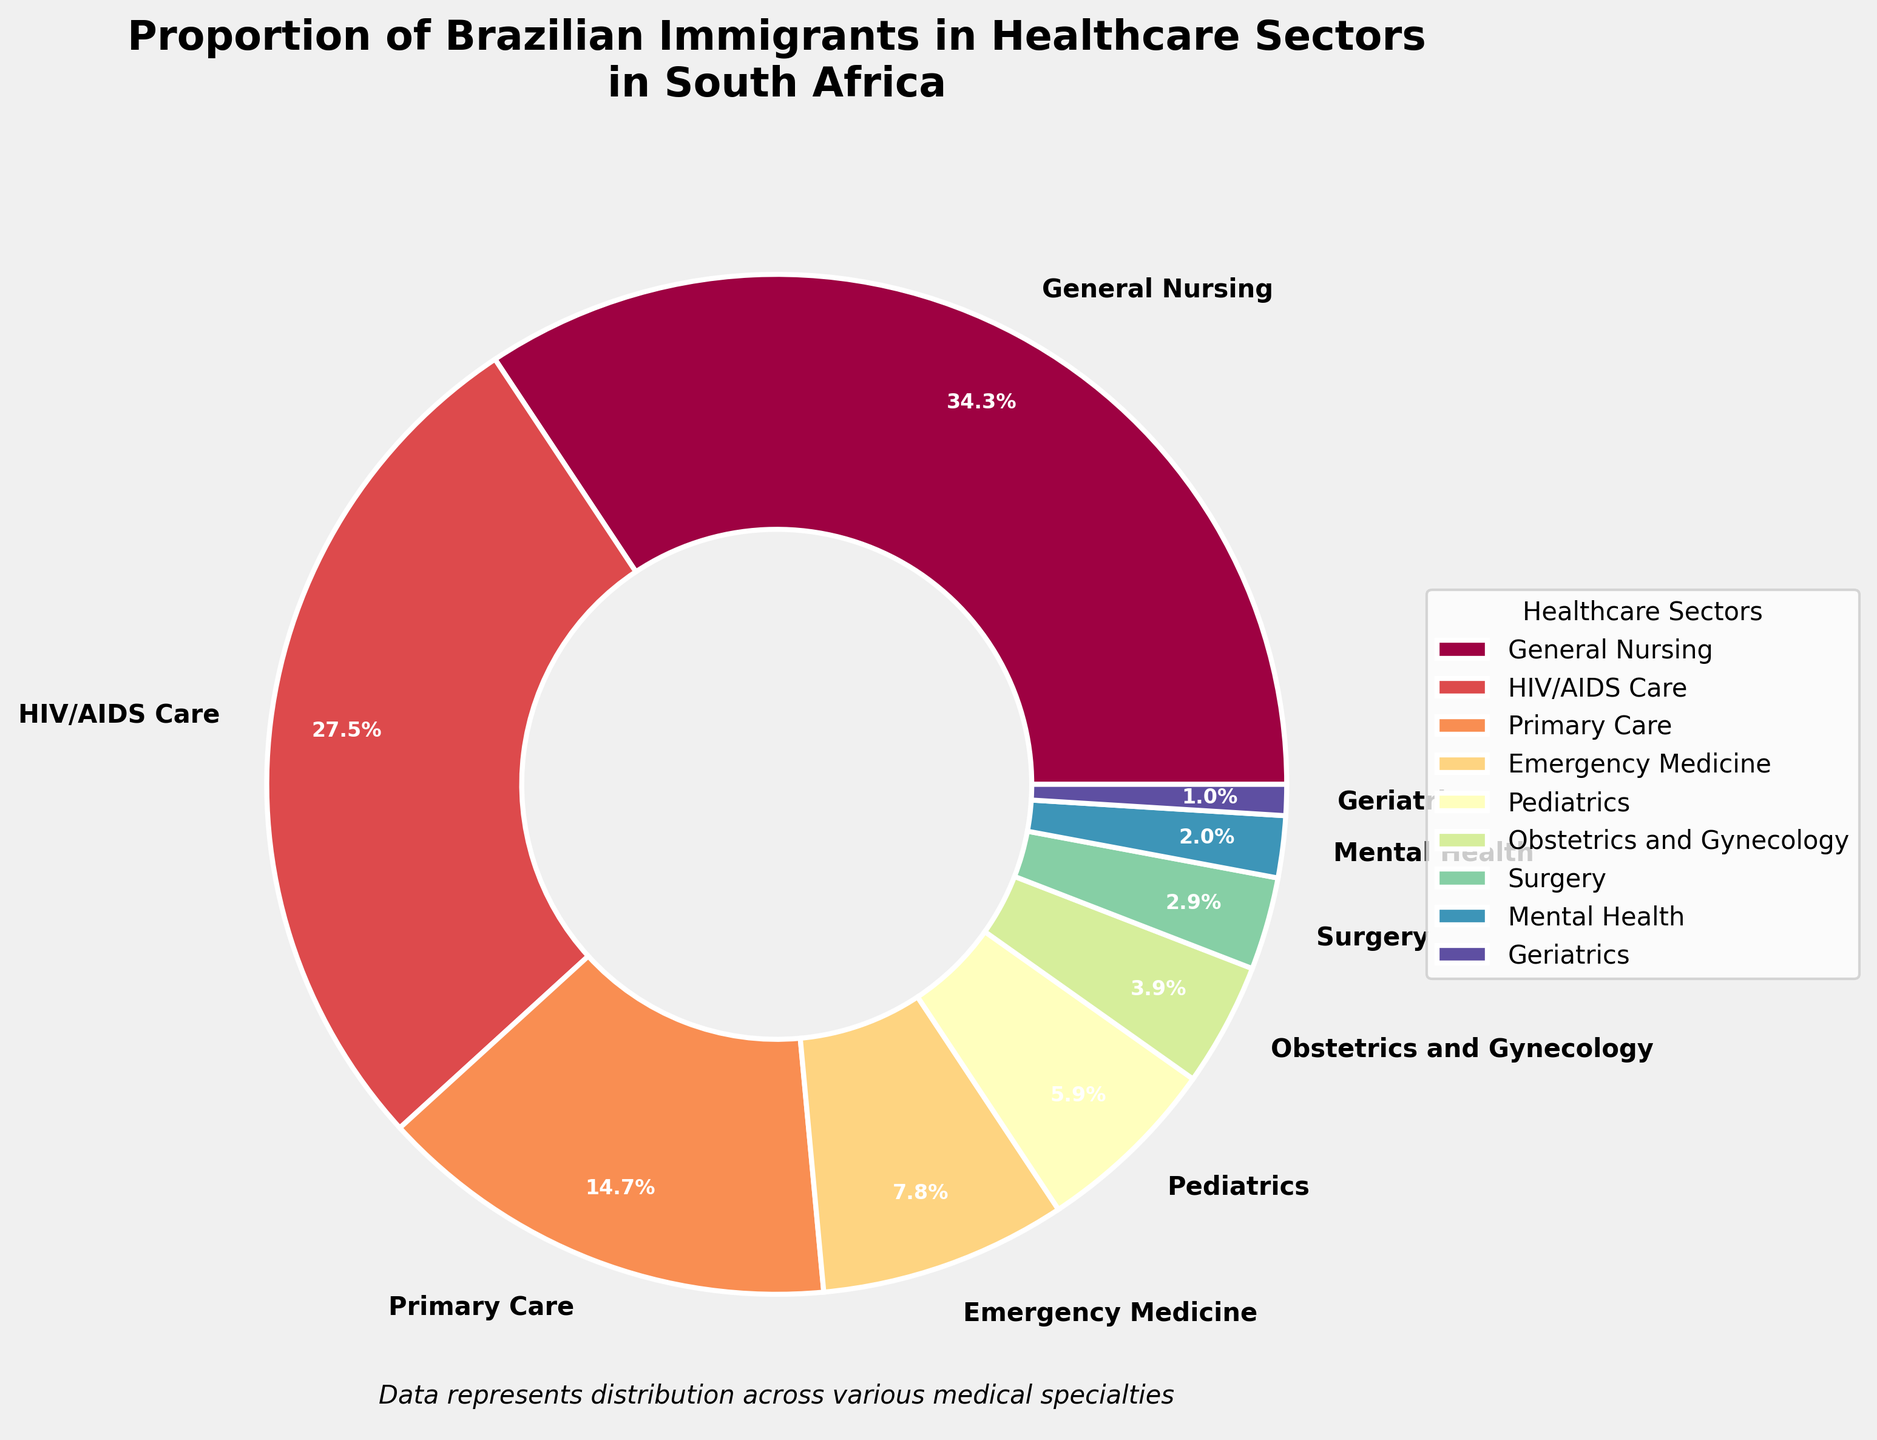What's the most common healthcare sector for Brazilian immigrants in South Africa? The figure shows a pie chart with different healthcare sectors and their respective proportions. Identify the sector with the largest slice.
Answer: General Nursing What percentage of Brazilian immigrants work in HIV/AIDS Care? The pie chart labels each sector with its corresponding percentage. Look for the label "HIV/AIDS Care".
Answer: 28% What is the combined percentage of Brazilian immigrants working in Emergency Medicine, Pediatrics, and Obstetrics and Gynecology? Add the percentages of Emergency Medicine (8%), Pediatrics (6%), and Obstetrics and Gynecology (4%) shown in the chart. 8% + 6% + 4% = 18%.
Answer: 18% Which sector has a lower percentage, Primary Care or Emergency Medicine? Compare the percentage values for Primary Care (15%) and Emergency Medicine (8%) as labeled in the chart.
Answer: Emergency Medicine How much smaller is the proportion of Brazilian immigrants in Surgery compared to General Nursing? Subtract the percentage of Surgery (3%) from the percentage of General Nursing (35%). 35% - 3% = 32%.
Answer: 32% What proportion of Brazilian immigrants work in sectors outside General Nursing and HIV/AIDS Care? Subtract the sum of General Nursing (35%) and HIV/AIDS Care (28%) from 100%. 100% - (35% + 28%) = 37%.
Answer: 37% Which healthcare sector has the smallest proportion of Brazilian immigrants? Identify the smallest slice in the pie chart and check its label.
Answer: Geriatrics How much greater is the proportion of Brazilian immigrants in Pediatrics compared to Mental Health? Subtract the percentage of Mental Health (2%) from Pediatrics (6%). 6% - 2% = 4%.
Answer: 4% Does the combined proportion of Brazilian immigrants in Primary Care and Surgery exceed the proportion in HIV/AIDS Care? Add the percentages of Primary Care (15%) and Surgery (3%) and compare the sum to that of HIV/AIDS Care (28%). 15% + 3% = 18%, which is less than 28%.
Answer: No, it does not Why might General Nursing have the largest proportion of Brazilian immigrants in South Africa? Consider the broad applicability and demand for general nursing skills across various healthcare settings, which might attract more professionals.
Answer: General applicability and high demand 